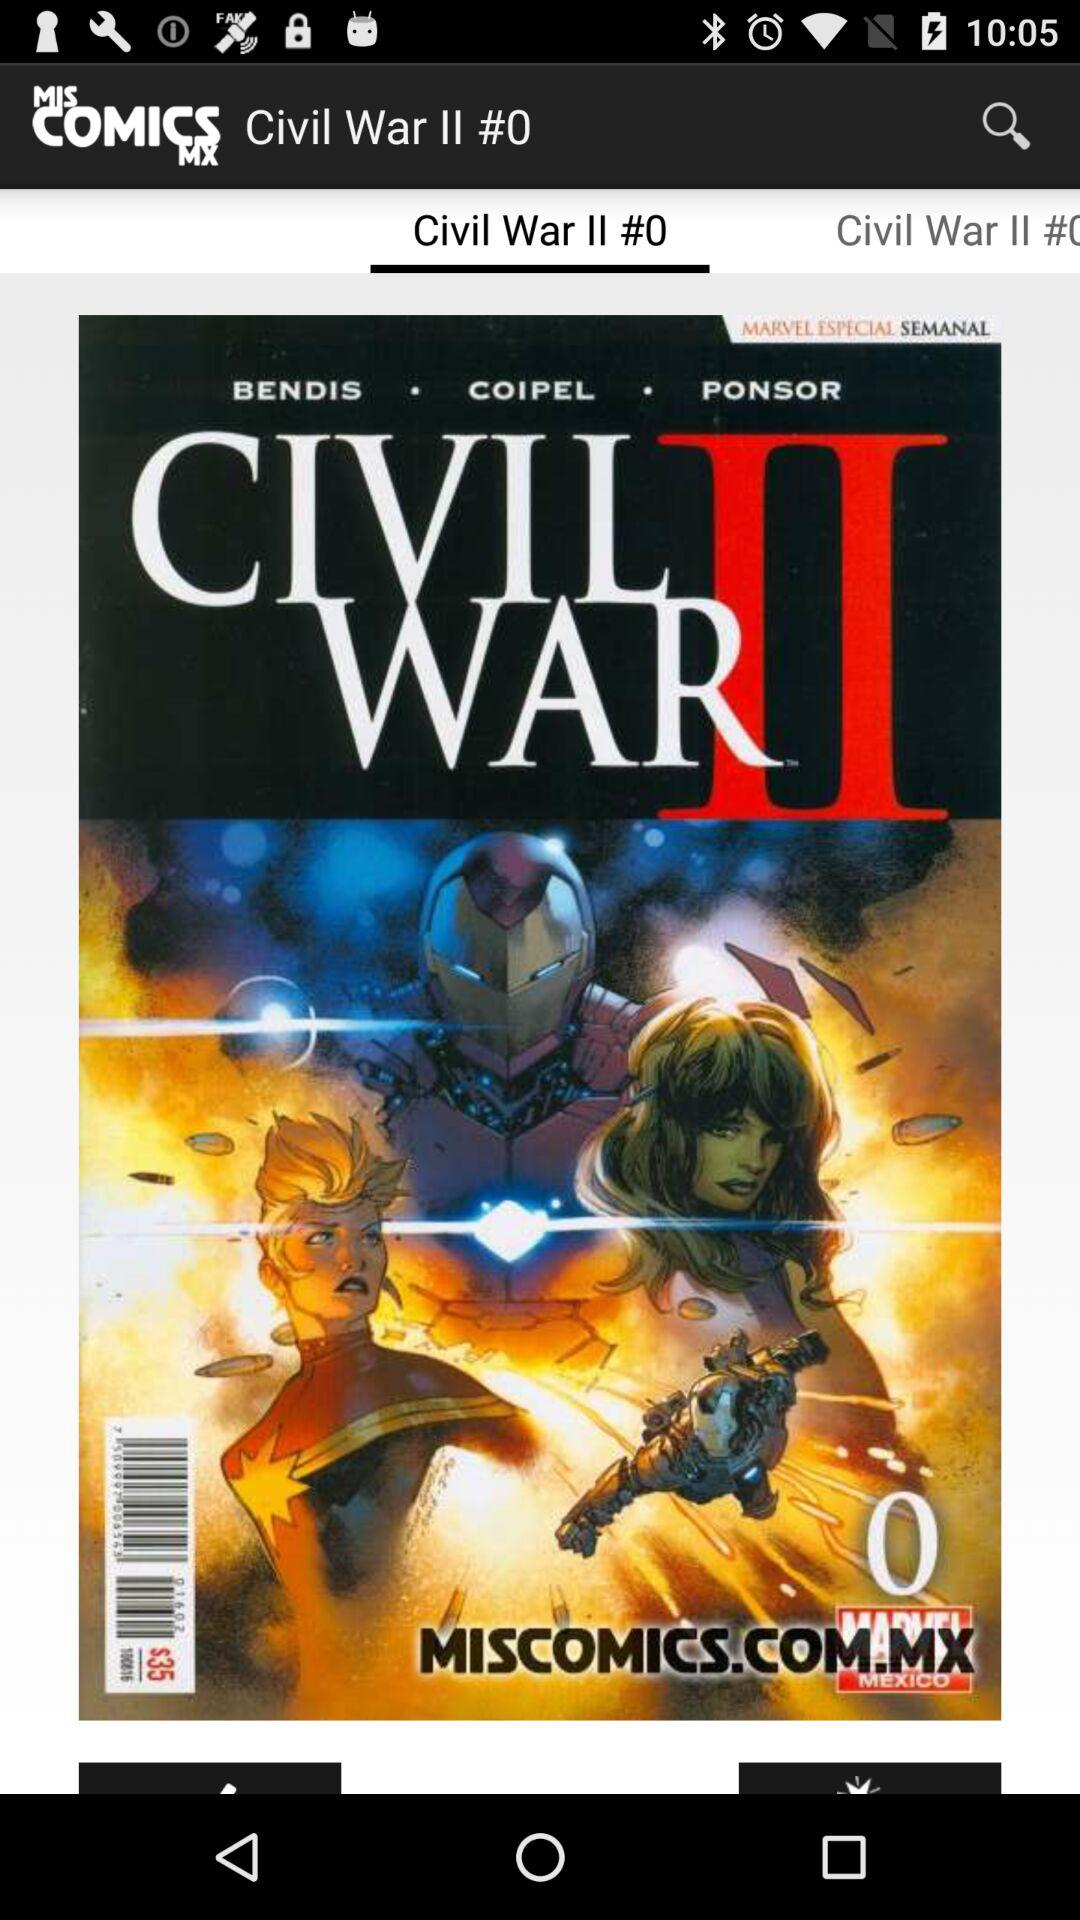Which tab is selected? The selected tab is "Civil War II #0". 